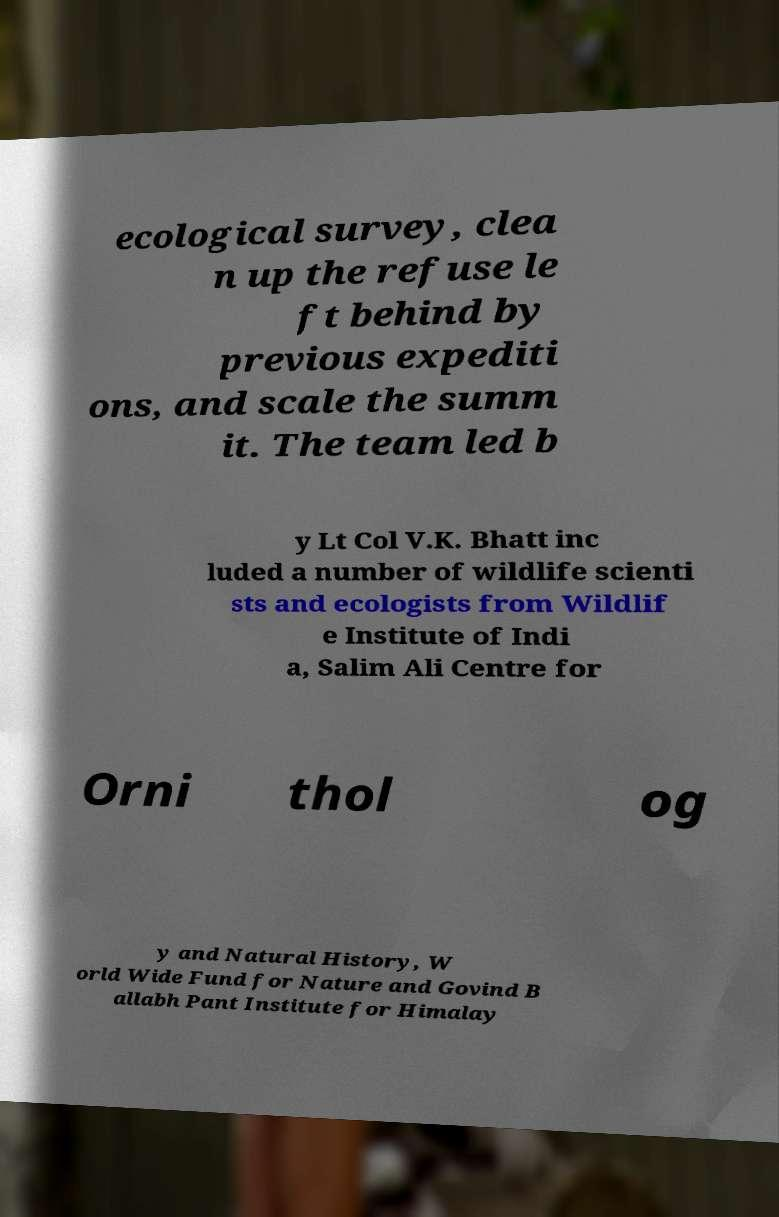What messages or text are displayed in this image? I need them in a readable, typed format. ecological survey, clea n up the refuse le ft behind by previous expediti ons, and scale the summ it. The team led b y Lt Col V.K. Bhatt inc luded a number of wildlife scienti sts and ecologists from Wildlif e Institute of Indi a, Salim Ali Centre for Orni thol og y and Natural History, W orld Wide Fund for Nature and Govind B allabh Pant Institute for Himalay 